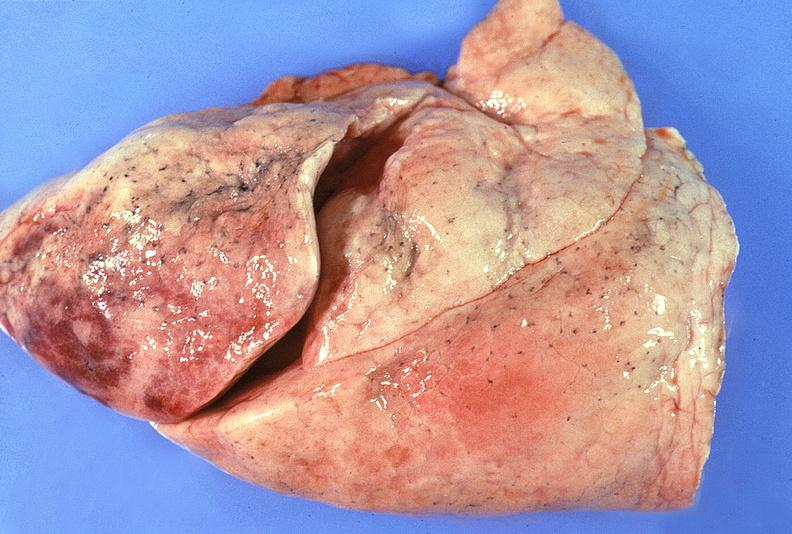what does this image show?
Answer the question using a single word or phrase. Normal lung 